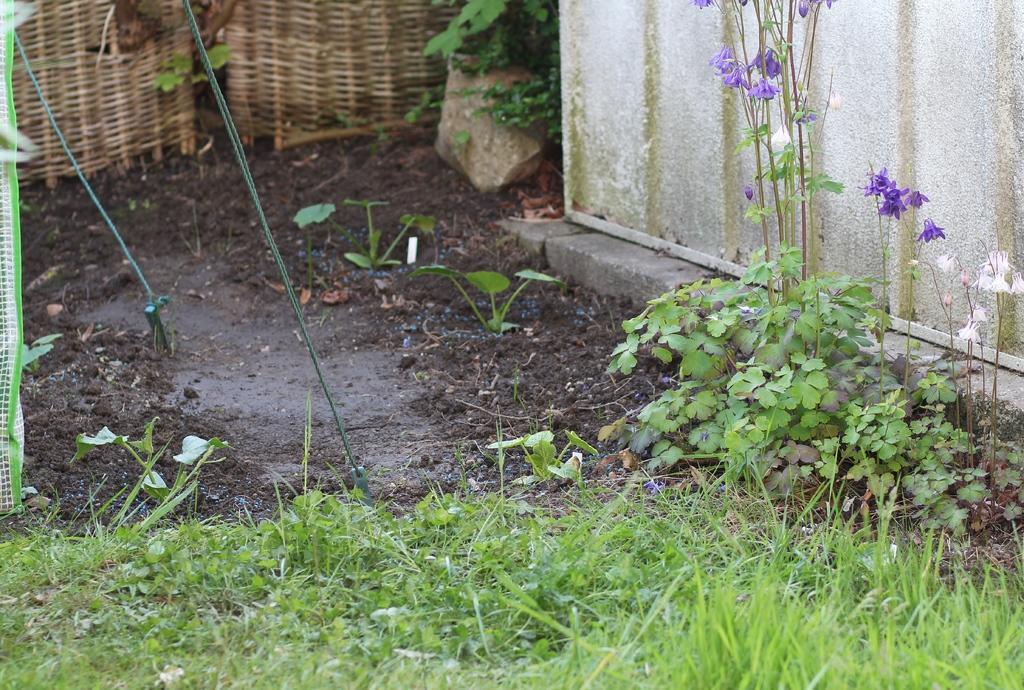Please provide a concise description of this image. This picture shows few flowers to the plants and we see grass on the ground and we see a stone. 